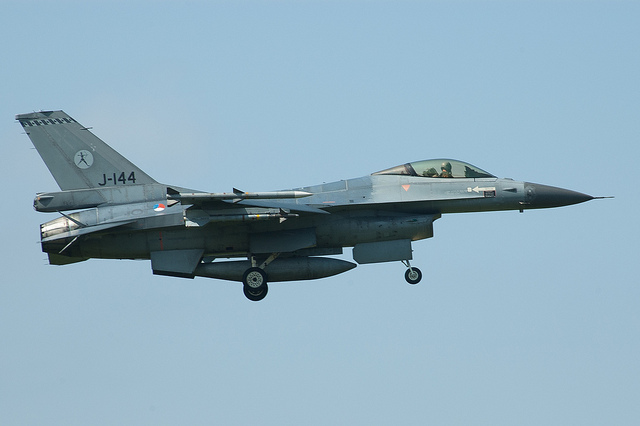Read all the text in this image. J-144 